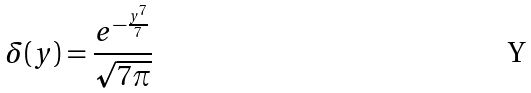Convert formula to latex. <formula><loc_0><loc_0><loc_500><loc_500>\delta ( y ) = \frac { e ^ { - \frac { y ^ { 7 } } { 7 } } } { \sqrt { 7 \pi } }</formula> 